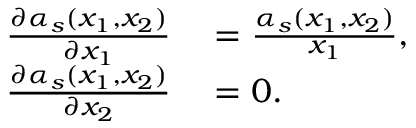Convert formula to latex. <formula><loc_0><loc_0><loc_500><loc_500>\begin{array} { r l } { \frac { \partial \alpha _ { s } ( x _ { 1 } , x _ { 2 } ) } { \partial x _ { 1 } } } & = \frac { \alpha _ { s } ( x _ { 1 } , x _ { 2 } ) } { x _ { 1 } } , } \\ { \frac { \partial \alpha _ { s } ( x _ { 1 } , x _ { 2 } ) } { \partial x _ { 2 } } } & = 0 . } \end{array}</formula> 